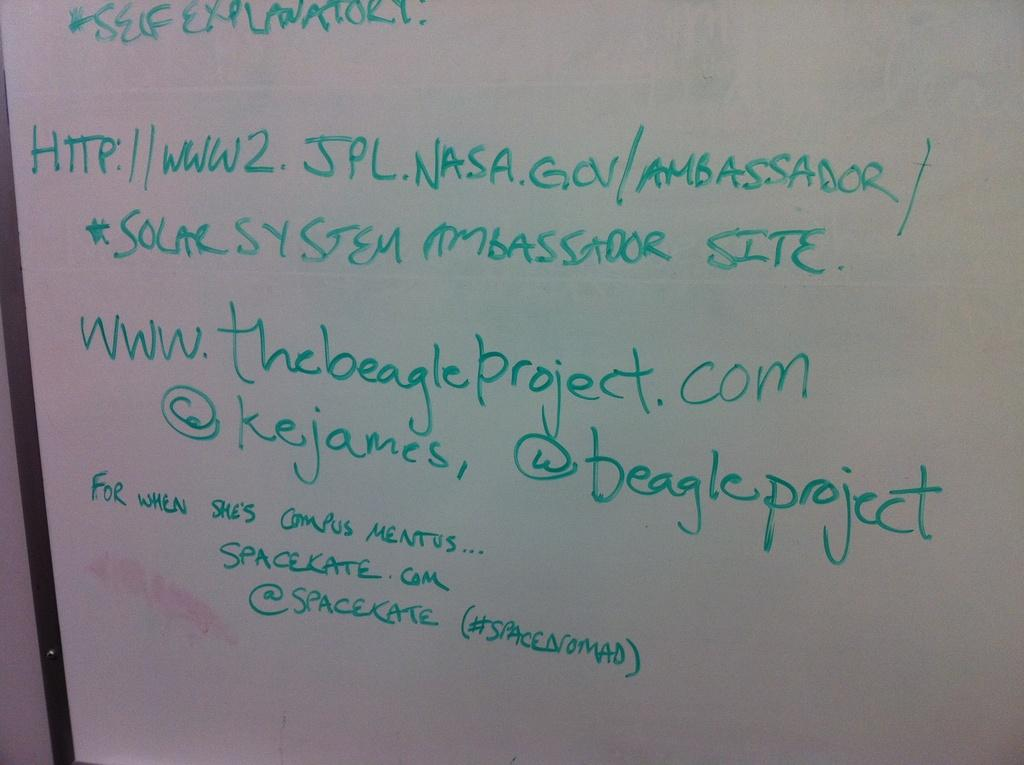<image>
Write a terse but informative summary of the picture. A white board has the words self explanatory written in green at the top. 